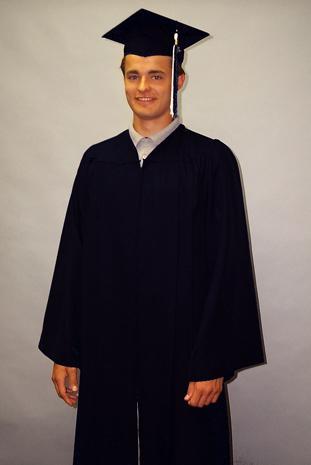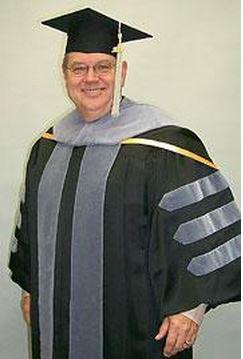The first image is the image on the left, the second image is the image on the right. Considering the images on both sides, is "There are two graduates in the pair of images." valid? Answer yes or no. Yes. The first image is the image on the left, the second image is the image on the right. Considering the images on both sides, is "One of the images has one man and at least 3 women." valid? Answer yes or no. No. 